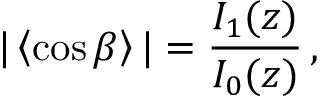Convert formula to latex. <formula><loc_0><loc_0><loc_500><loc_500>| \left \langle \cos \beta \right \rangle | = \frac { I _ { 1 } ( z ) } { I _ { 0 } ( z ) } \, ,</formula> 